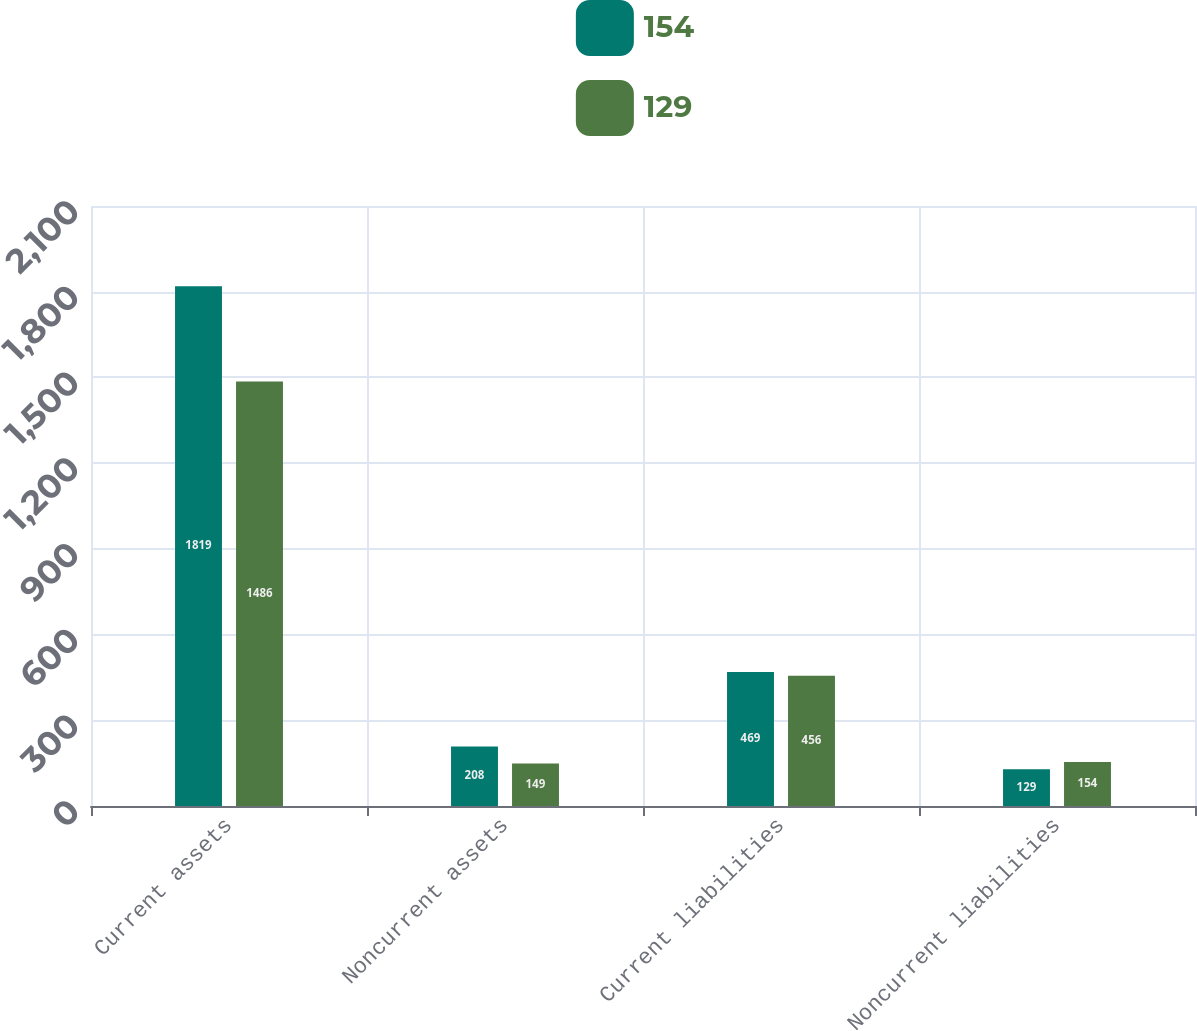Convert chart to OTSL. <chart><loc_0><loc_0><loc_500><loc_500><stacked_bar_chart><ecel><fcel>Current assets<fcel>Noncurrent assets<fcel>Current liabilities<fcel>Noncurrent liabilities<nl><fcel>154<fcel>1819<fcel>208<fcel>469<fcel>129<nl><fcel>129<fcel>1486<fcel>149<fcel>456<fcel>154<nl></chart> 